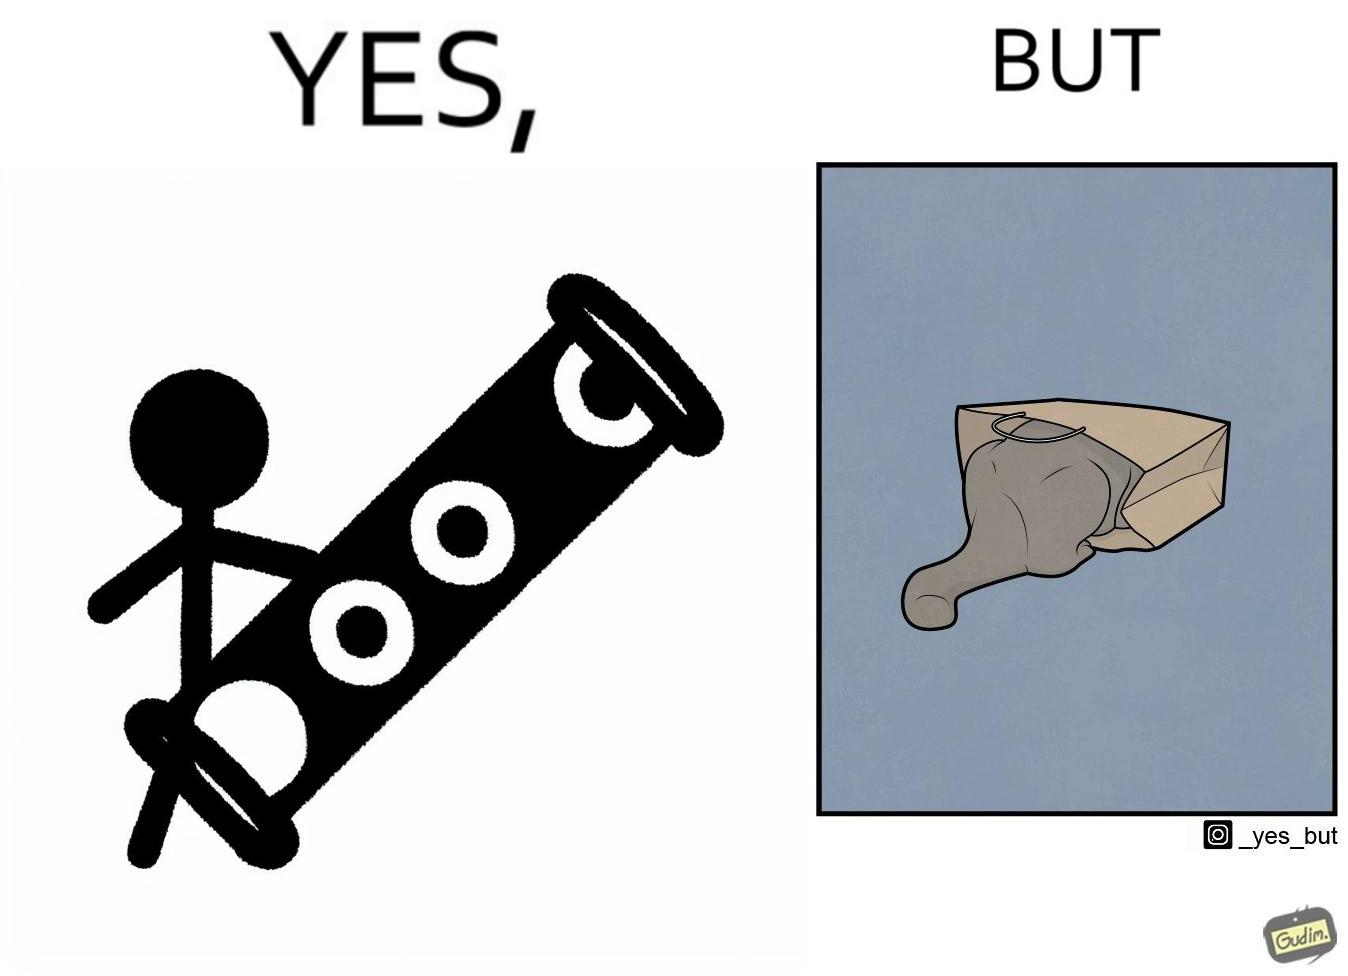Is this image satirical or non-satirical? Yes, this image is satirical. 